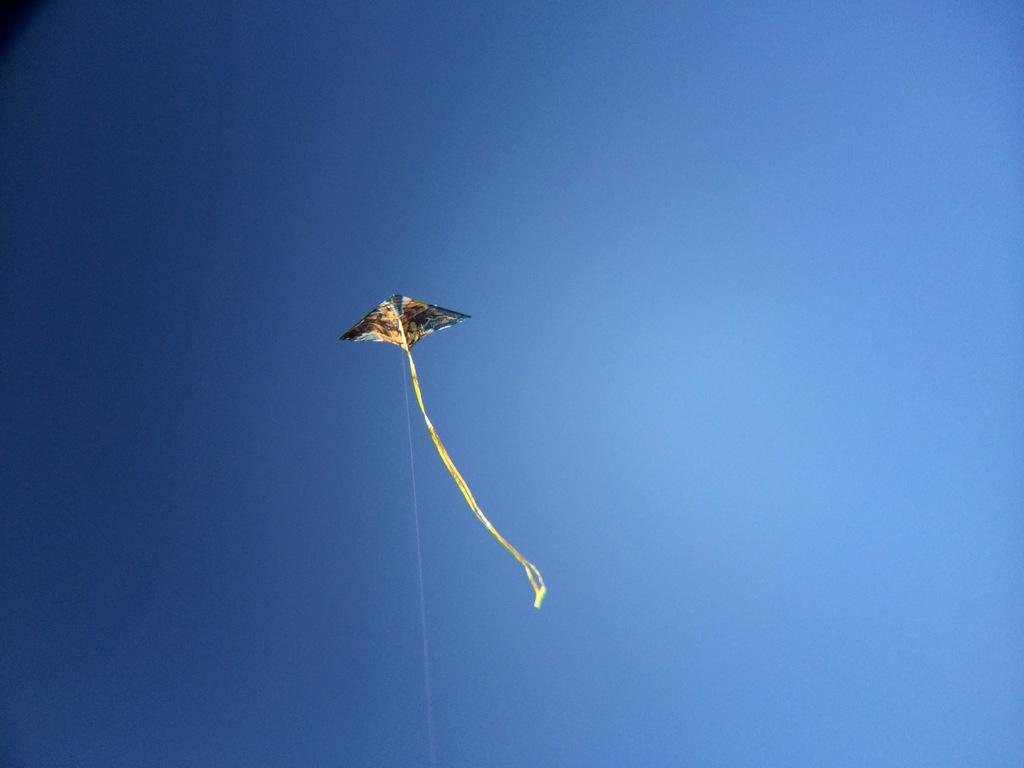What is flying in the air in the image? There is a kite in the air in the image. How is the kite connected to the ground? There is a thread associated with the kite. What can be seen in the background of the image? The sky is visible in the background of the image. What is the color of the sky in the image? The color of the sky is blue. How many friends are sleeping in the image? There are no friends or sleeping individuals present in the image; it features a kite in the air. 